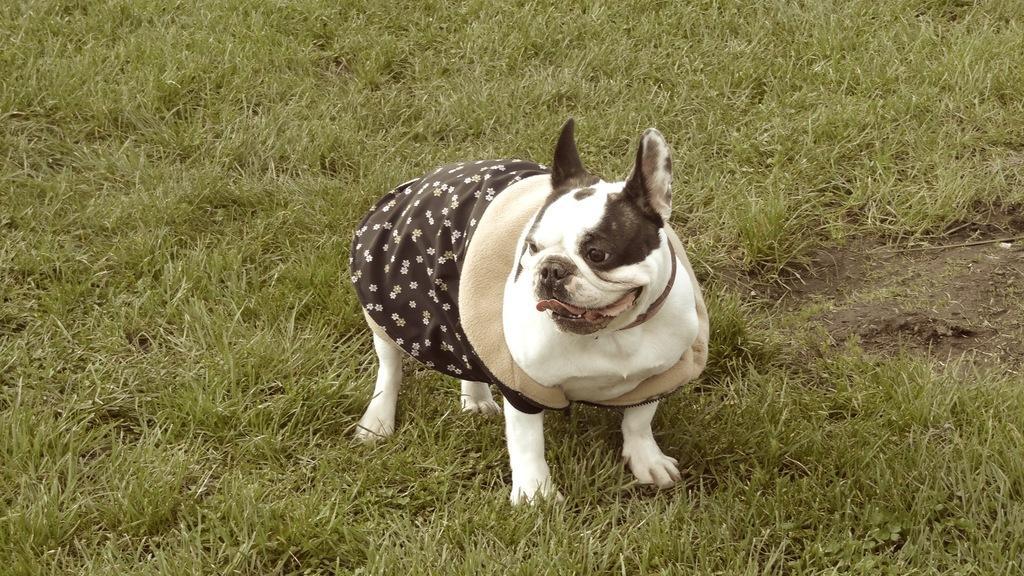Describe this image in one or two sentences. There is a dog on green grass. 